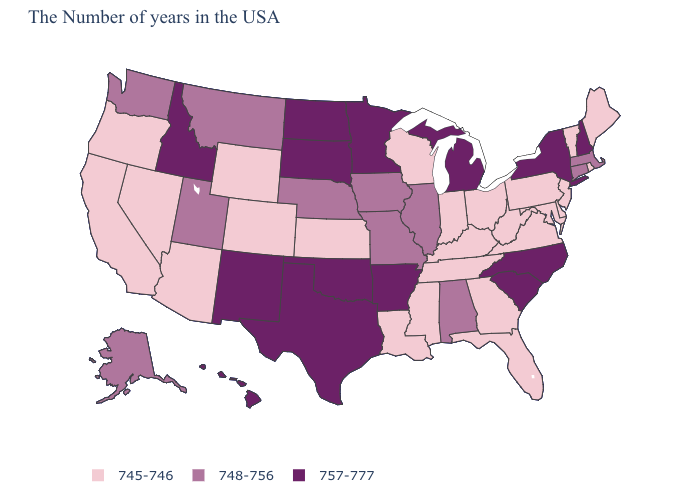Does the map have missing data?
Concise answer only. No. Does the map have missing data?
Keep it brief. No. What is the value of Hawaii?
Concise answer only. 757-777. What is the highest value in the USA?
Write a very short answer. 757-777. How many symbols are there in the legend?
Write a very short answer. 3. Among the states that border Kansas , does Colorado have the lowest value?
Quick response, please. Yes. Among the states that border Kansas , does Oklahoma have the highest value?
Keep it brief. Yes. Among the states that border West Virginia , which have the highest value?
Write a very short answer. Maryland, Pennsylvania, Virginia, Ohio, Kentucky. Which states have the highest value in the USA?
Be succinct. New Hampshire, New York, North Carolina, South Carolina, Michigan, Arkansas, Minnesota, Oklahoma, Texas, South Dakota, North Dakota, New Mexico, Idaho, Hawaii. What is the lowest value in the South?
Keep it brief. 745-746. What is the value of Kansas?
Concise answer only. 745-746. What is the highest value in the USA?
Concise answer only. 757-777. Among the states that border Arizona , does New Mexico have the highest value?
Short answer required. Yes. Does Texas have the highest value in the USA?
Give a very brief answer. Yes. What is the value of Arkansas?
Short answer required. 757-777. 